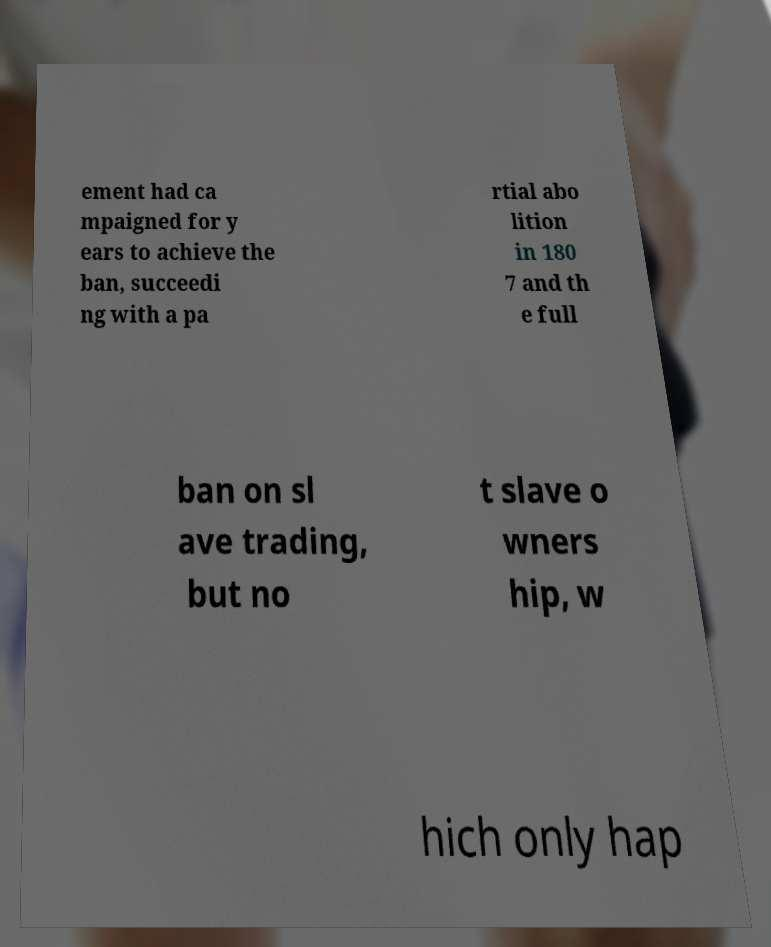What messages or text are displayed in this image? I need them in a readable, typed format. ement had ca mpaigned for y ears to achieve the ban, succeedi ng with a pa rtial abo lition in 180 7 and th e full ban on sl ave trading, but no t slave o wners hip, w hich only hap 